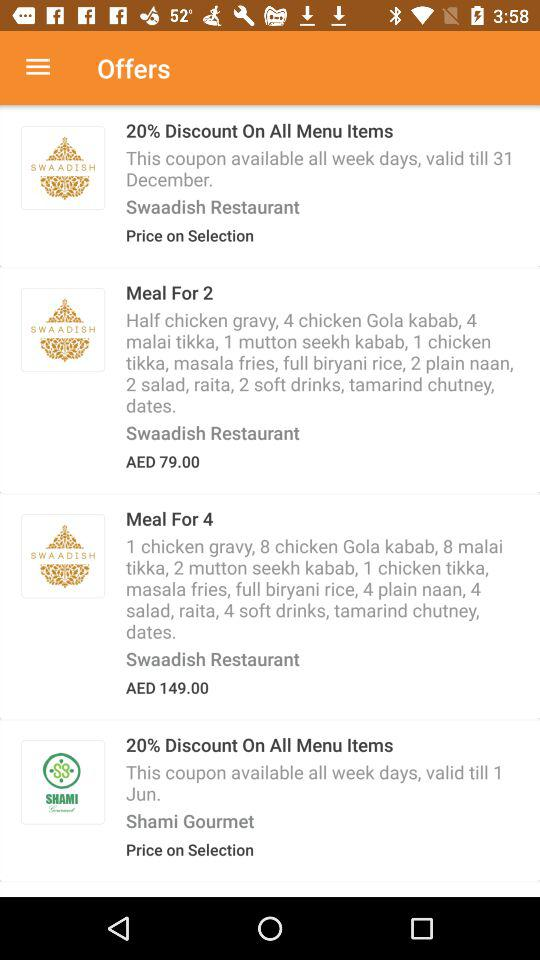How many restaurants have a discount of 20%?
Answer the question using a single word or phrase. 2 